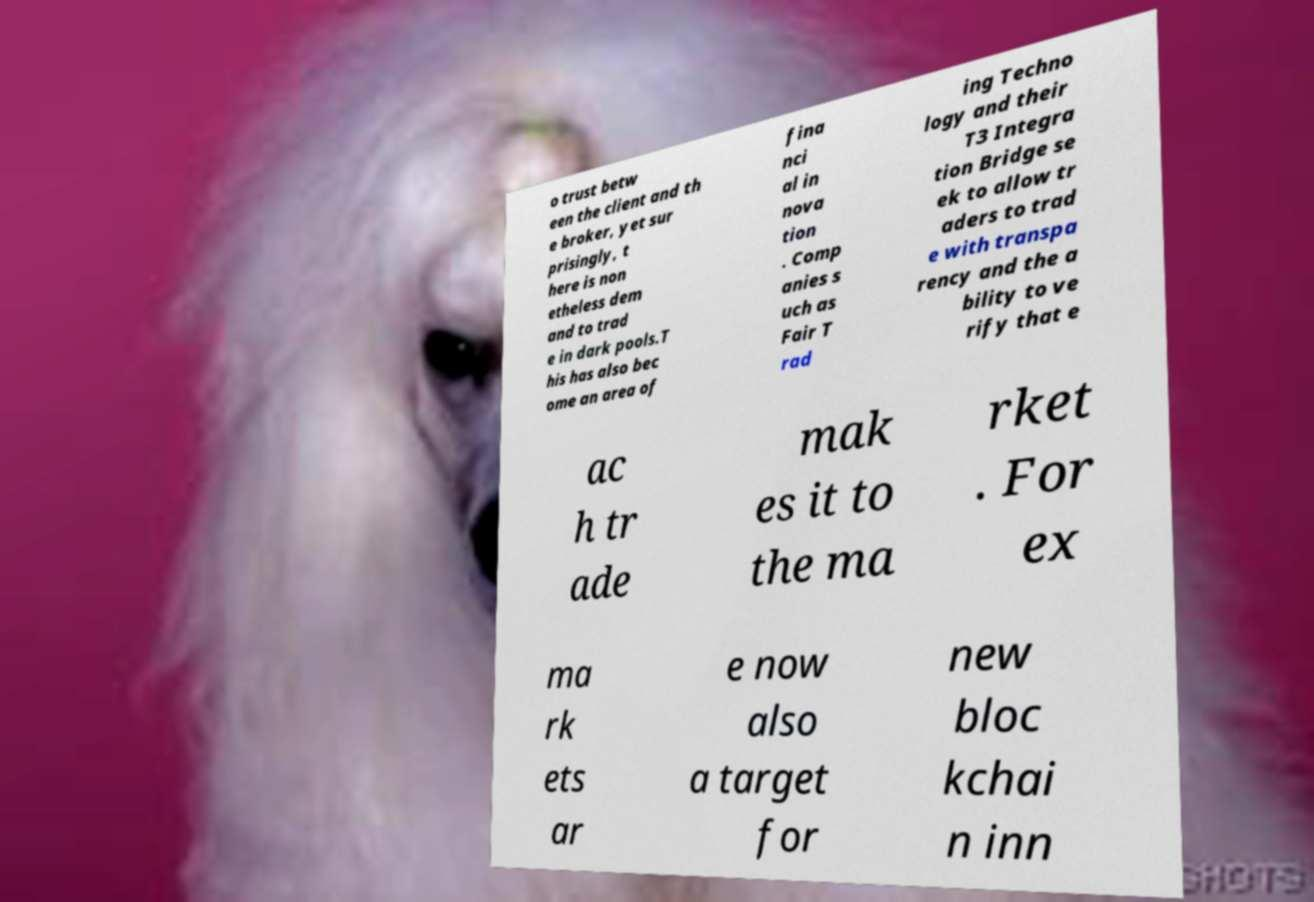Could you extract and type out the text from this image? o trust betw een the client and th e broker, yet sur prisingly, t here is non etheless dem and to trad e in dark pools.T his has also bec ome an area of fina nci al in nova tion . Comp anies s uch as Fair T rad ing Techno logy and their T3 Integra tion Bridge se ek to allow tr aders to trad e with transpa rency and the a bility to ve rify that e ac h tr ade mak es it to the ma rket . For ex ma rk ets ar e now also a target for new bloc kchai n inn 